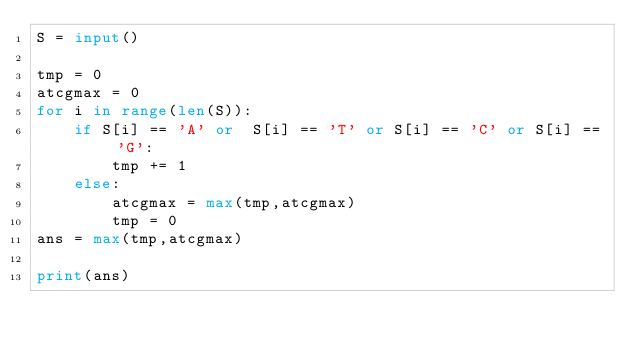Convert code to text. <code><loc_0><loc_0><loc_500><loc_500><_Python_>S = input()

tmp = 0
atcgmax = 0
for i in range(len(S)):
    if S[i] == 'A' or  S[i] == 'T' or S[i] == 'C' or S[i] == 'G':
        tmp += 1
    else:
        atcgmax = max(tmp,atcgmax)
        tmp = 0
ans = max(tmp,atcgmax)

print(ans)</code> 